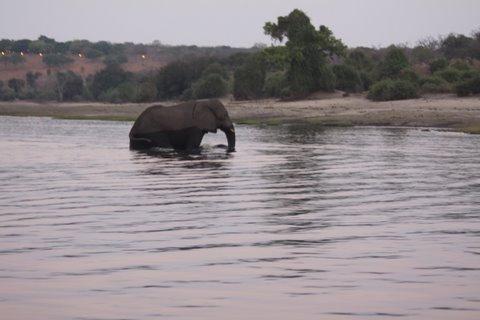How many animals are in the picture?
Give a very brief answer. 1. How many elephants are there?
Give a very brief answer. 1. How many people are standing behind the counter?
Give a very brief answer. 0. 